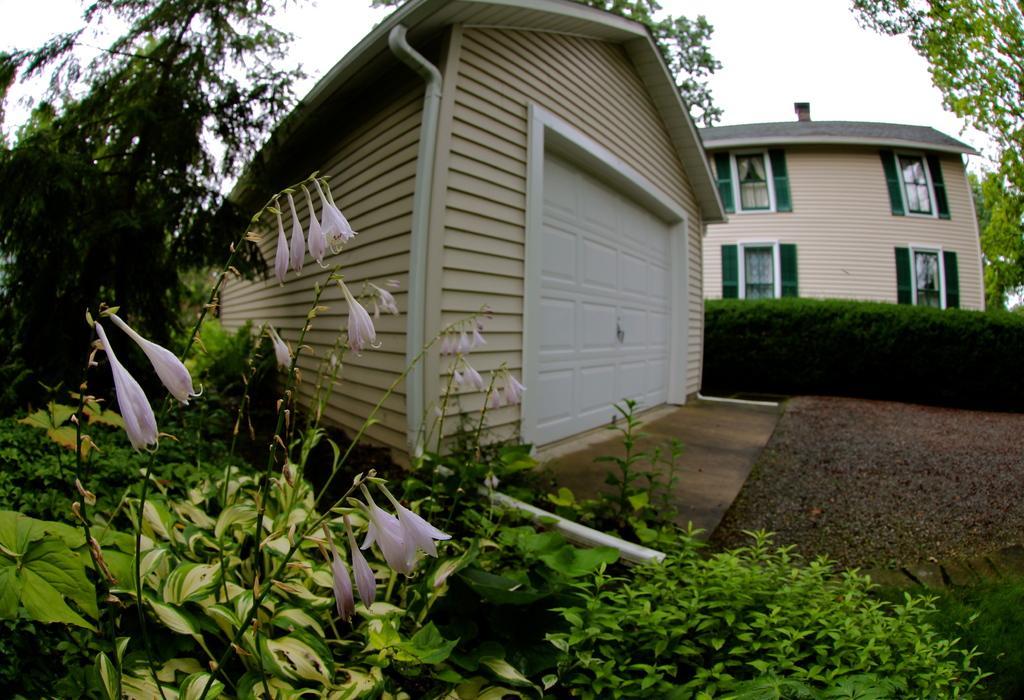In one or two sentences, can you explain what this image depicts? In this picture we can see the building. At the bottom we can see plants and grass. On the left we can see pink color flowers. In the background we can see many trees. In the center we can see the shed and pipe. In the top right there is a sky. On the building we can see the windows. 